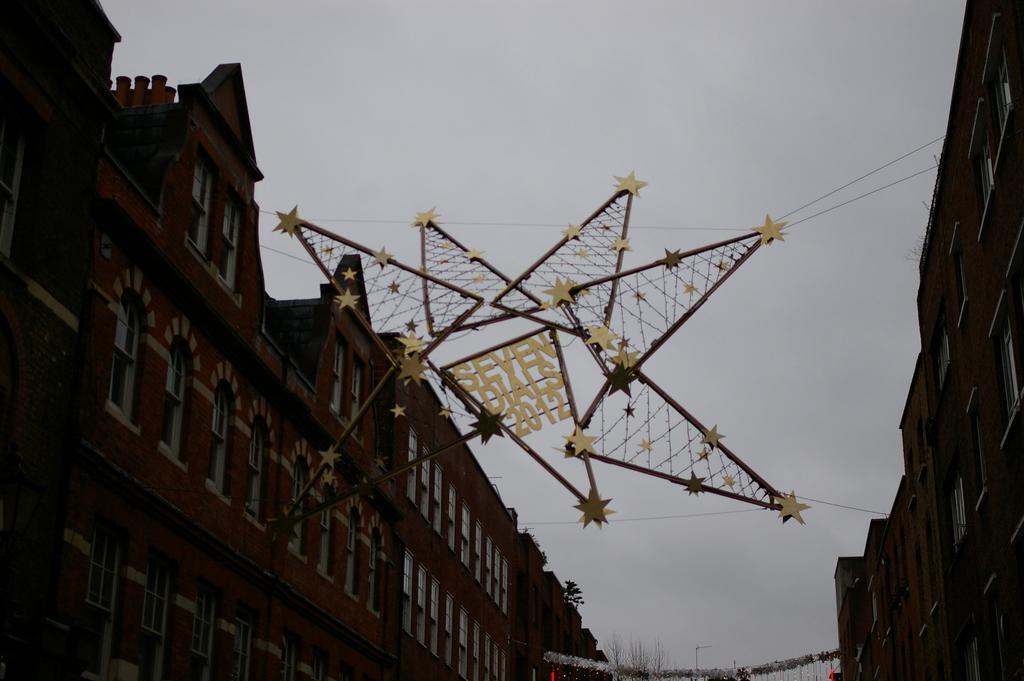How would you summarize this image in a sentence or two? These are the buildings with the windows. I can see a decorative item, which is hanging between the buildings. This is the sky. 